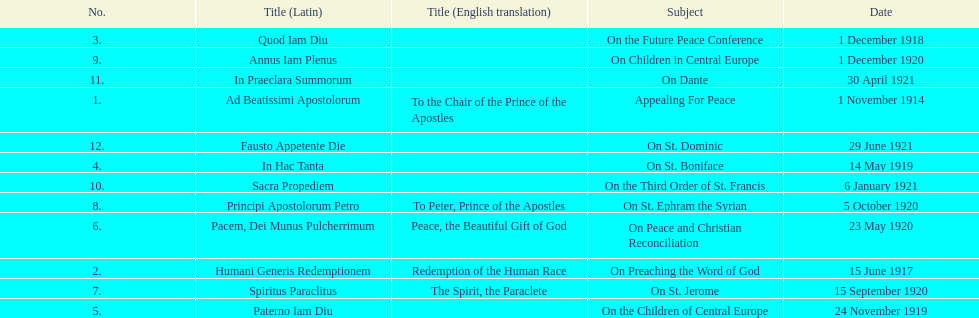Other than january how many encyclicals were in 1921? 2. 